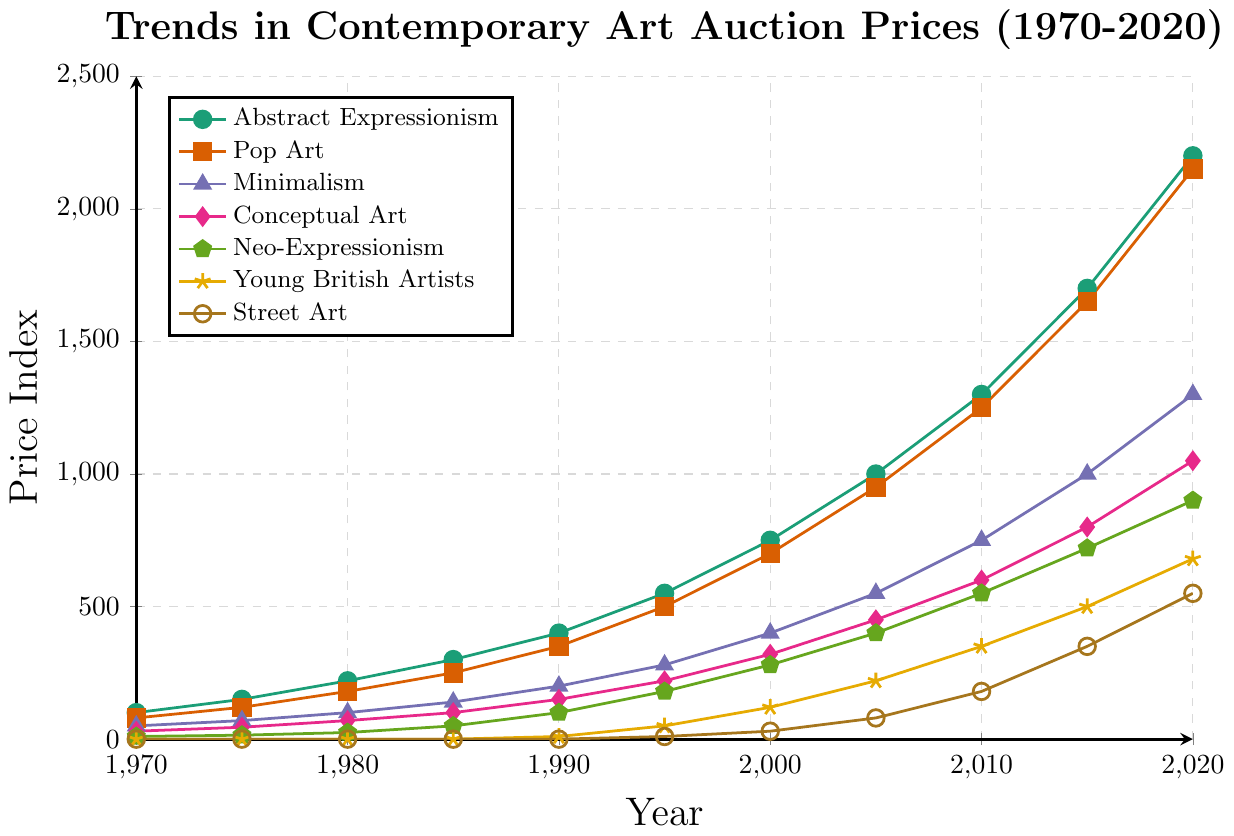What's the overall trend in auction prices for Abstract Expressionism from 1970 to 2020? The line for Abstract Expressionism rises consistently from 100 in 1970 to 2200 in 2020, indicating a general upward trend without any dips.
Answer: Upward trend Which artistic movement had the highest auction prices in 2020? The highest line point in 2020 is for Abstract Expressionism, at 2200. While other movements also rose considerably, Abstract Expressionism maintained the highest price index.
Answer: Abstract Expressionism How do the auction prices for Minimalism in 1985 compare to those for Neo-Expressionism in 2000? Minimalism in 1985 is at 140, while Neo-Expressionism in 2000 is at 280, so Neo-Expressionism in 2000 is twice as high.
Answer: Neo-Expressionism is higher What's the difference in auction prices for Pop Art between 1995 and 2000? Pop Art prices in 1995 are 500 and in 2000 are 700. Subtracting 500 from 700 gives us a 200-point increase.
Answer: 200 Which movement experienced the most significant price growth from 1990 to 2020? Abstract Expressionism grew from 400 to 2200, an increase of 1800, which is the largest among all the movements.
Answer: Abstract Expressionism How did the value of Young British Artists change from 1990 to 2020? In 1990, the value is at the initial point of 10, growing to 680 in 2020, showing a significant increase of 670.
Answer: 670 increase Is Conceptual Art more valuable than Minimalism throughout the 50 years? By examining their respective lines, Minimalism is consistently above Conceptual Art, indicating higher values for Minimalism throughout the period.
Answer: No Between which years did Street Art see the most substantial growth? The most substantial growth for Street Art happened between 2010 and 2015, where it jumped from 180 to 350.
Answer: 2010-2015 What is the combined price index of all movements in 1980? Summing up the price indices: 220 (Abstract Expressionism) + 180 (Pop Art) + 100 (Minimalism) + 70 (Conceptual Art) + 25 (Neo-Expressionism) + 0 (Young British Artists) + 0 (Street Art) = 595.
Answer: 595 How does the trajectory of auction prices for Neo-Expressionism compare to that of Conceptual Art between 1995 and 2020? Between 1995 and 2020, Neo-Expressionism starts at 180 and finishes at 900, while Conceptual Art starts at 220 and finishes at 1050. Although both show growth, Conceptual Art consistently maintains higher values.
Answer: Conceptual Art consistently higher 